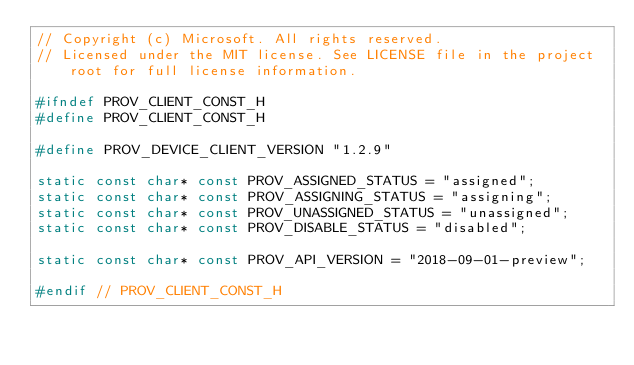<code> <loc_0><loc_0><loc_500><loc_500><_C_>// Copyright (c) Microsoft. All rights reserved.
// Licensed under the MIT license. See LICENSE file in the project root for full license information.

#ifndef PROV_CLIENT_CONST_H
#define PROV_CLIENT_CONST_H

#define PROV_DEVICE_CLIENT_VERSION "1.2.9"

static const char* const PROV_ASSIGNED_STATUS = "assigned";
static const char* const PROV_ASSIGNING_STATUS = "assigning";
static const char* const PROV_UNASSIGNED_STATUS = "unassigned";
static const char* const PROV_DISABLE_STATUS = "disabled";

static const char* const PROV_API_VERSION = "2018-09-01-preview";

#endif // PROV_CLIENT_CONST_H
</code> 